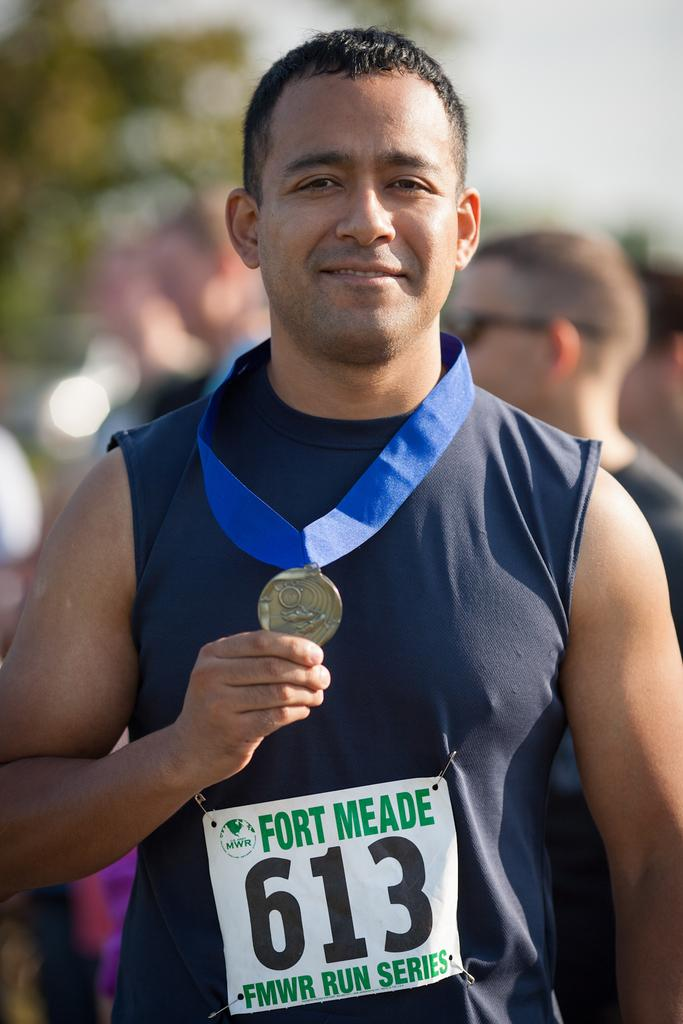<image>
Present a compact description of the photo's key features. a man holding a medal after the FMWR run series 